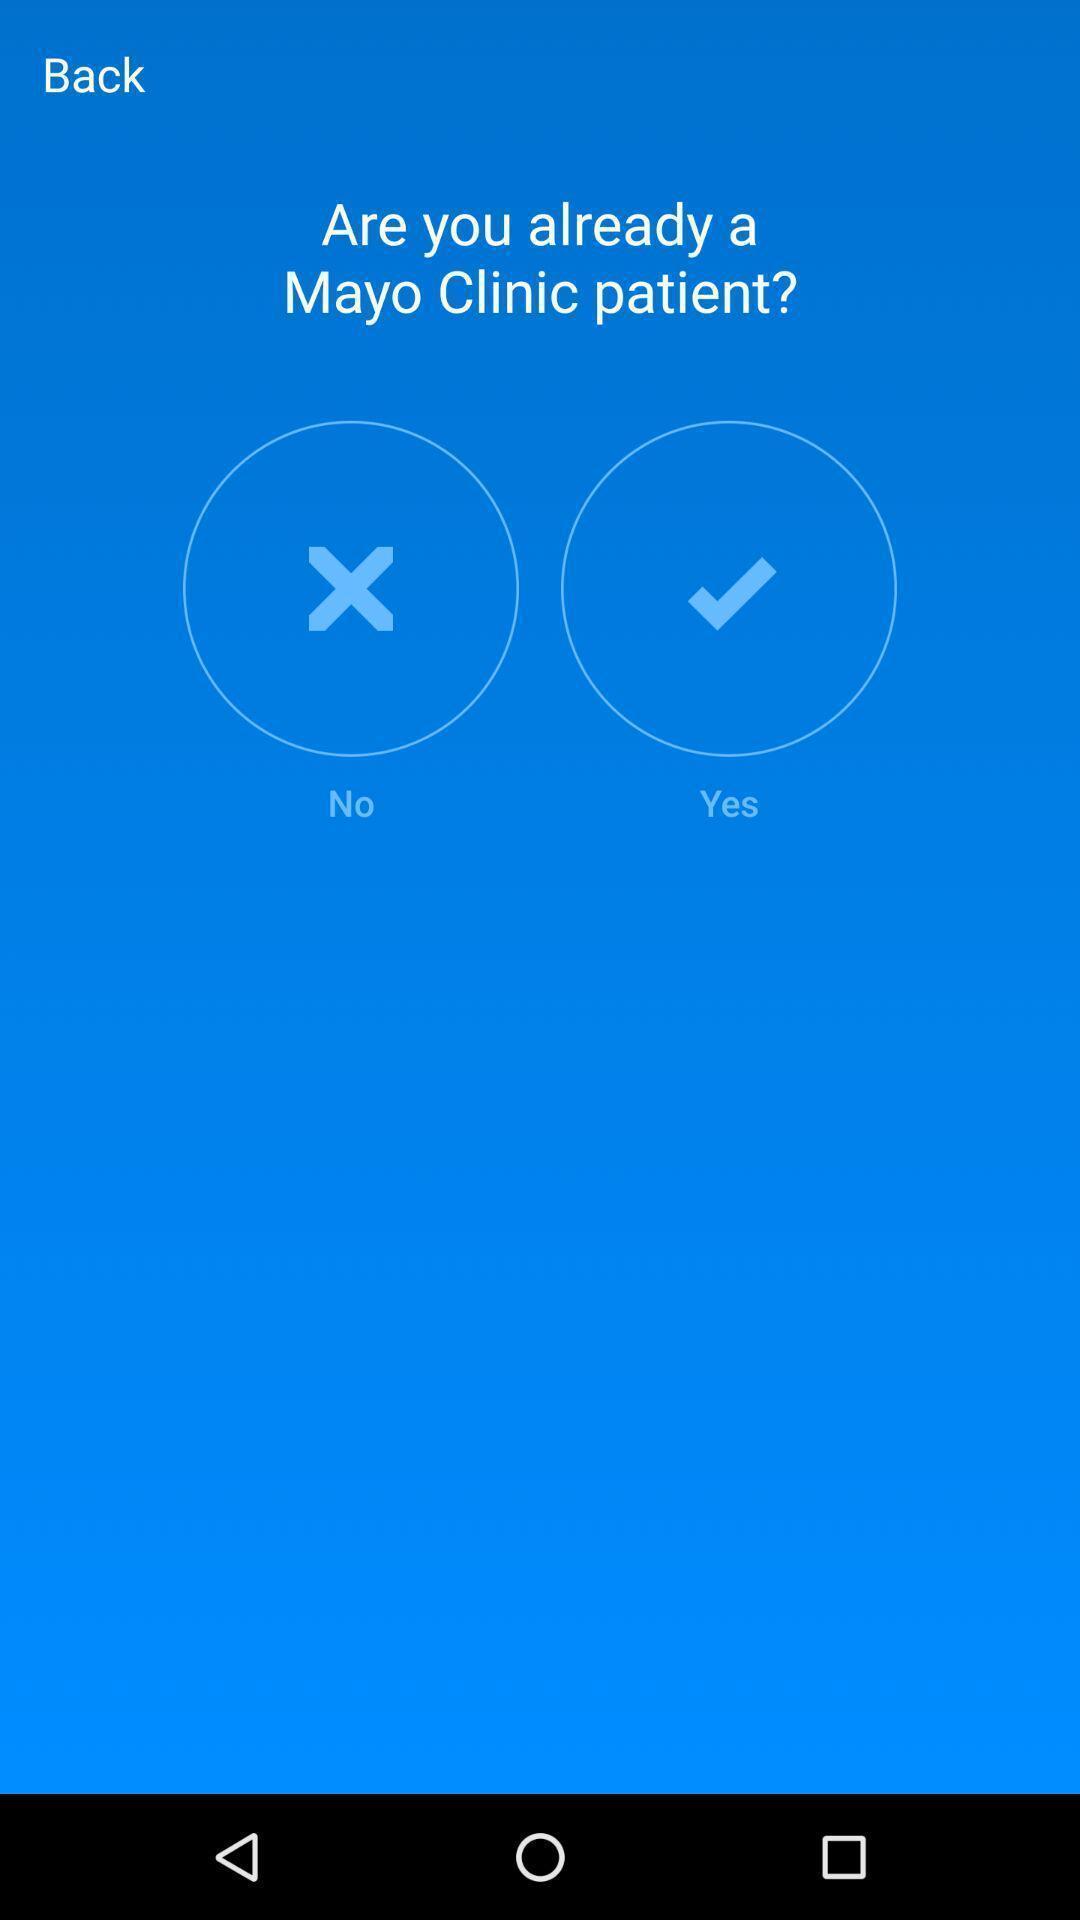Provide a detailed account of this screenshot. Page shows to answer a question in the health app. 